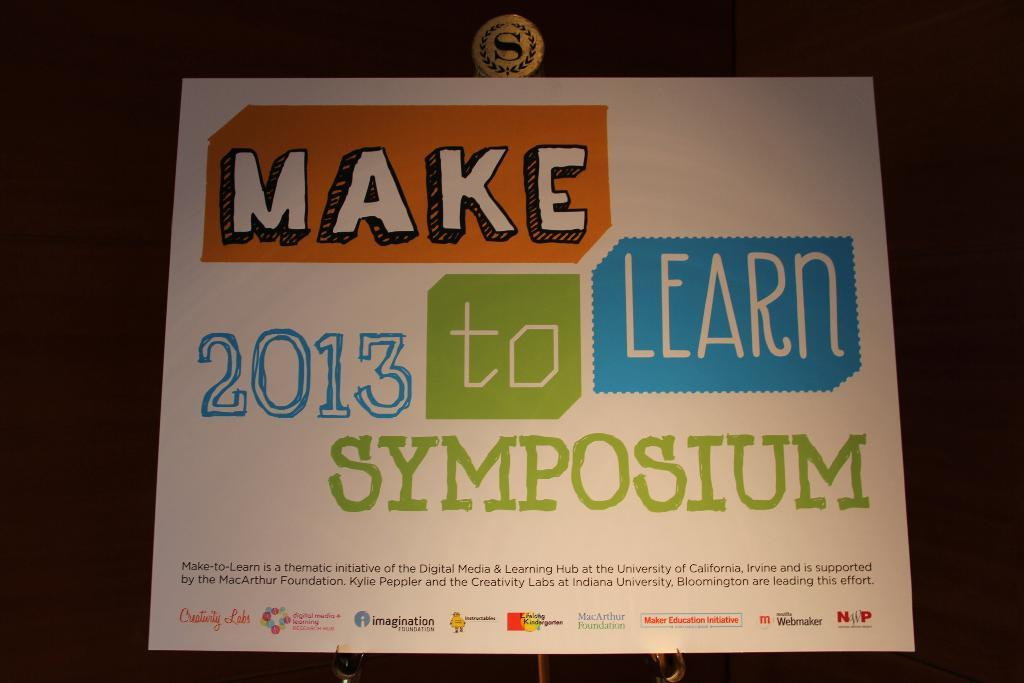What is the main object in the image? There is a board in the image. What color is the board? The board is white. What can be seen on the board? There is writing on the board. What is the color of the background in the image? The background of the image is dark. What type of punishment is being given to the rabbit in the image? There is no rabbit present in the image, and therefore no punishment can be observed. 